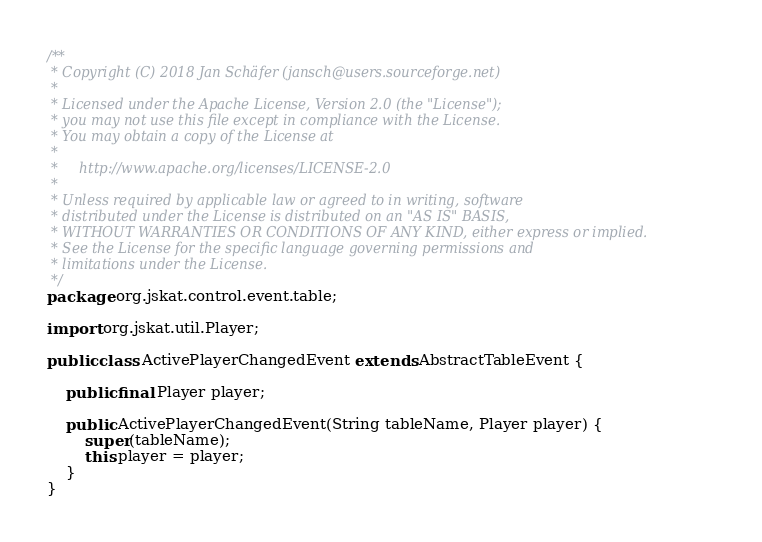Convert code to text. <code><loc_0><loc_0><loc_500><loc_500><_Java_>/**
 * Copyright (C) 2018 Jan Schäfer (jansch@users.sourceforge.net)
 *
 * Licensed under the Apache License, Version 2.0 (the "License");
 * you may not use this file except in compliance with the License.
 * You may obtain a copy of the License at
 *
 *     http://www.apache.org/licenses/LICENSE-2.0
 *
 * Unless required by applicable law or agreed to in writing, software
 * distributed under the License is distributed on an "AS IS" BASIS,
 * WITHOUT WARRANTIES OR CONDITIONS OF ANY KIND, either express or implied.
 * See the License for the specific language governing permissions and
 * limitations under the License.
 */
package org.jskat.control.event.table;

import org.jskat.util.Player;

public class ActivePlayerChangedEvent extends AbstractTableEvent {

	public final Player player;

	public ActivePlayerChangedEvent(String tableName, Player player) {
		super(tableName);
		this.player = player;
	}
}
</code> 